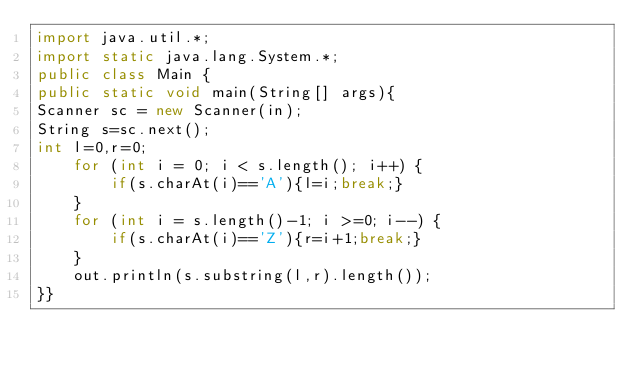Convert code to text. <code><loc_0><loc_0><loc_500><loc_500><_Java_>import java.util.*;
import static java.lang.System.*;
public class Main {
public static void main(String[] args){
Scanner sc = new Scanner(in);
String s=sc.next();
int l=0,r=0;
    for (int i = 0; i < s.length(); i++) {
        if(s.charAt(i)=='A'){l=i;break;}
    }
    for (int i = s.length()-1; i >=0; i--) {
        if(s.charAt(i)=='Z'){r=i+1;break;}
    }
    out.println(s.substring(l,r).length());
}}</code> 